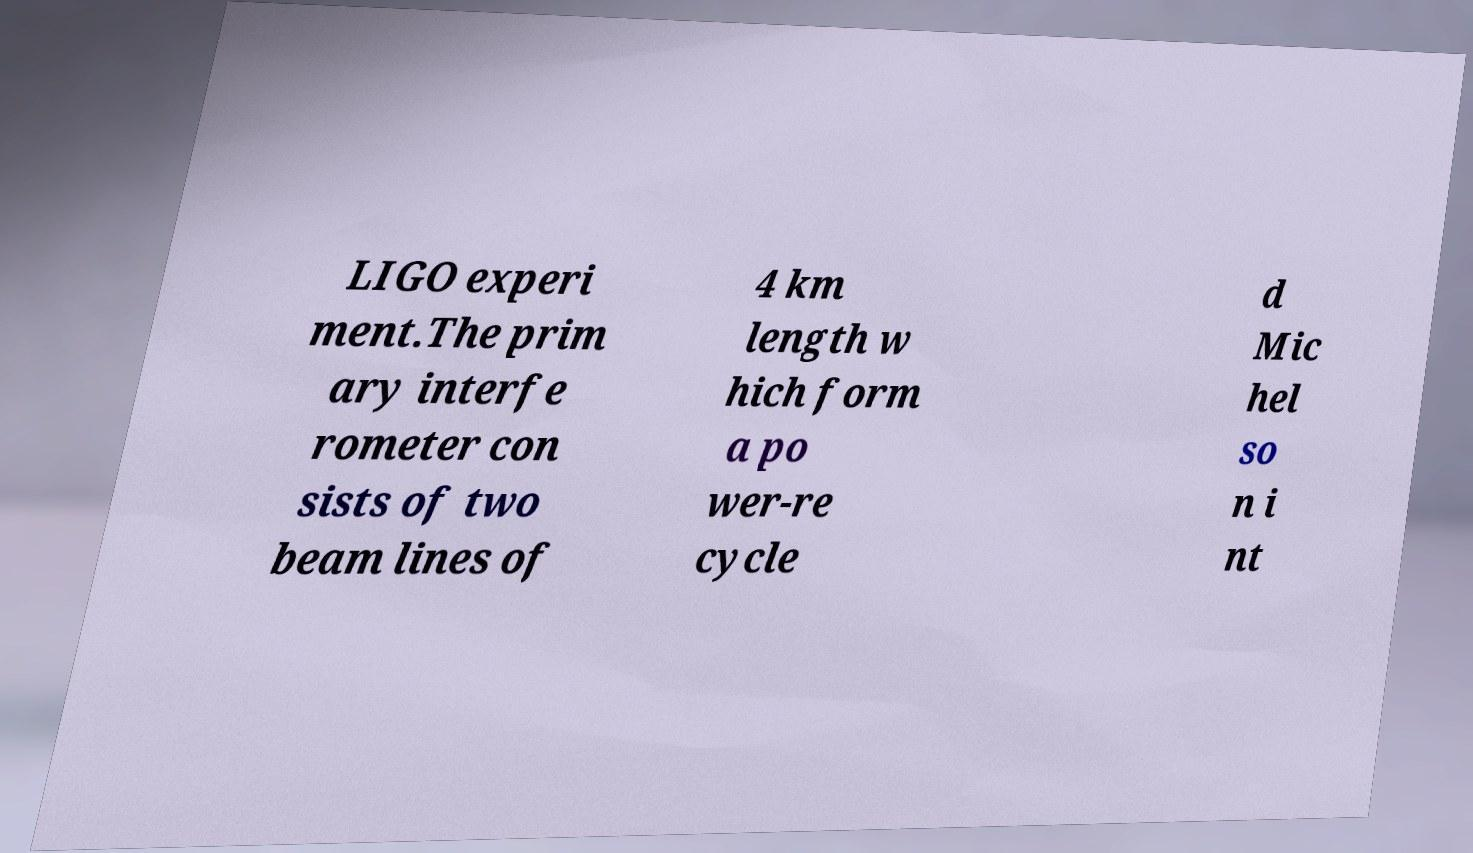I need the written content from this picture converted into text. Can you do that? LIGO experi ment.The prim ary interfe rometer con sists of two beam lines of 4 km length w hich form a po wer-re cycle d Mic hel so n i nt 